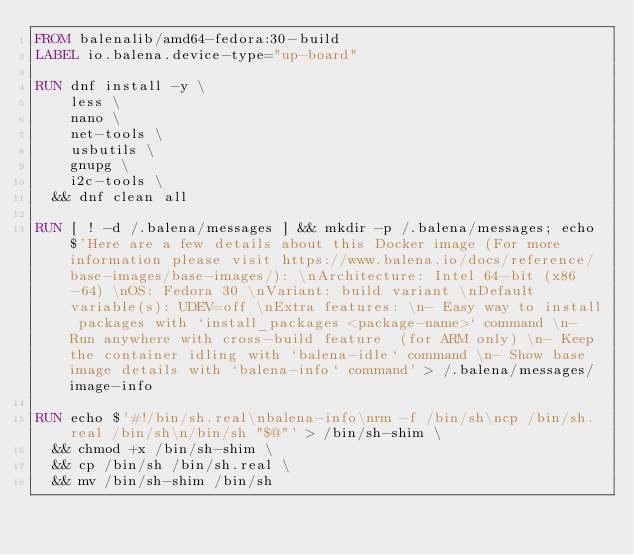<code> <loc_0><loc_0><loc_500><loc_500><_Dockerfile_>FROM balenalib/amd64-fedora:30-build
LABEL io.balena.device-type="up-board"

RUN dnf install -y \
		less \
		nano \
		net-tools \
		usbutils \
		gnupg \
		i2c-tools \
	&& dnf clean all

RUN [ ! -d /.balena/messages ] && mkdir -p /.balena/messages; echo $'Here are a few details about this Docker image (For more information please visit https://www.balena.io/docs/reference/base-images/base-images/): \nArchitecture: Intel 64-bit (x86-64) \nOS: Fedora 30 \nVariant: build variant \nDefault variable(s): UDEV=off \nExtra features: \n- Easy way to install packages with `install_packages <package-name>` command \n- Run anywhere with cross-build feature  (for ARM only) \n- Keep the container idling with `balena-idle` command \n- Show base image details with `balena-info` command' > /.balena/messages/image-info

RUN echo $'#!/bin/sh.real\nbalena-info\nrm -f /bin/sh\ncp /bin/sh.real /bin/sh\n/bin/sh "$@"' > /bin/sh-shim \
	&& chmod +x /bin/sh-shim \
	&& cp /bin/sh /bin/sh.real \
	&& mv /bin/sh-shim /bin/sh</code> 